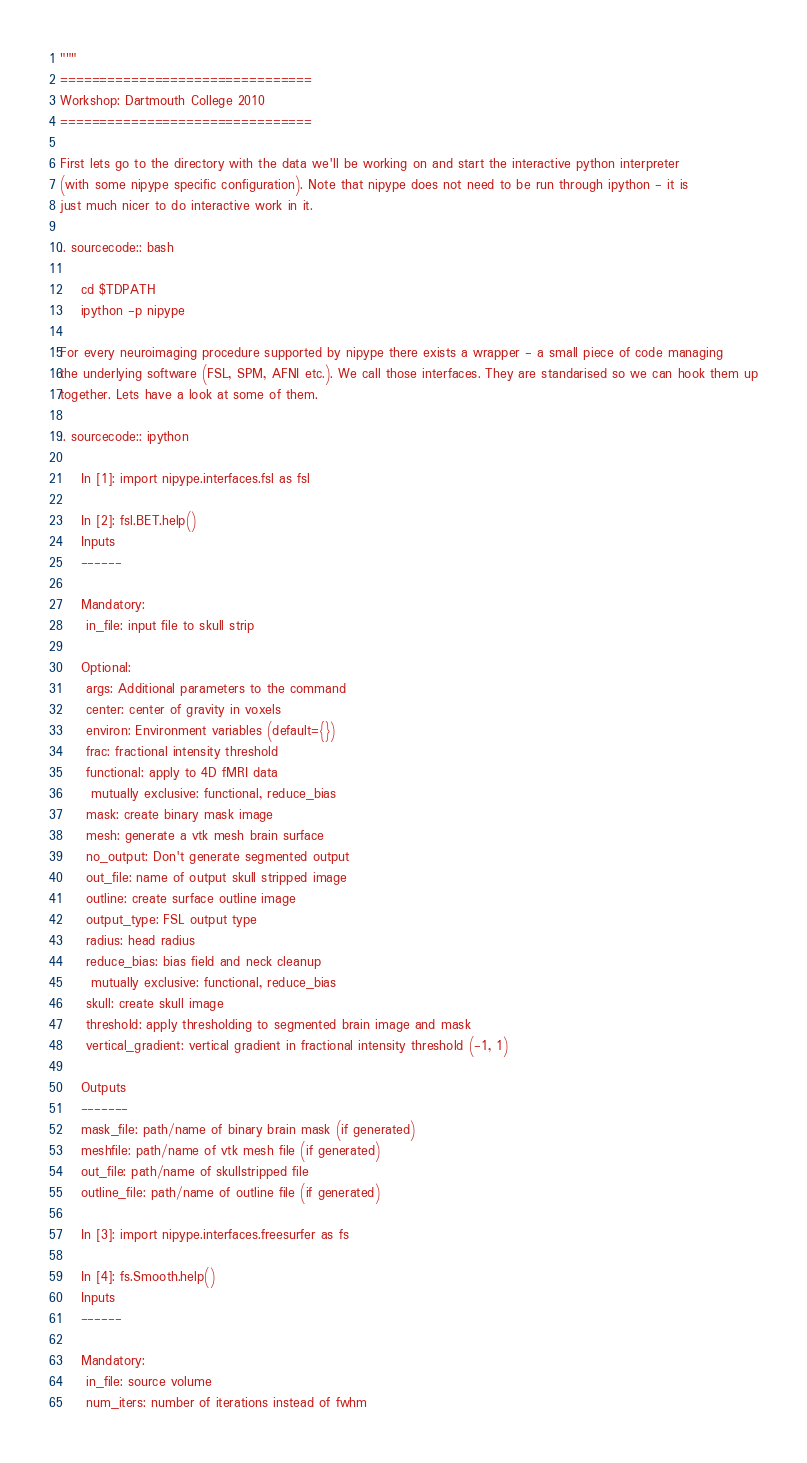Convert code to text. <code><loc_0><loc_0><loc_500><loc_500><_Python_>"""
================================
Workshop: Dartmouth College 2010
================================

First lets go to the directory with the data we'll be working on and start the interactive python interpreter
(with some nipype specific configuration). Note that nipype does not need to be run through ipython - it is
just much nicer to do interactive work in it.

.. sourcecode:: bash

    cd $TDPATH
    ipython -p nipype

For every neuroimaging procedure supported by nipype there exists a wrapper - a small piece of code managing
the underlying software (FSL, SPM, AFNI etc.). We call those interfaces. They are standarised so we can hook them up
together. Lets have a look at some of them.

.. sourcecode:: ipython

    In [1]: import nipype.interfaces.fsl as fsl

    In [2]: fsl.BET.help()
    Inputs
    ------

    Mandatory:
     in_file: input file to skull strip

    Optional:
     args: Additional parameters to the command
     center: center of gravity in voxels
     environ: Environment variables (default={})
     frac: fractional intensity threshold
     functional: apply to 4D fMRI data
      mutually exclusive: functional, reduce_bias
     mask: create binary mask image
     mesh: generate a vtk mesh brain surface
     no_output: Don't generate segmented output
     out_file: name of output skull stripped image
     outline: create surface outline image
     output_type: FSL output type
     radius: head radius
     reduce_bias: bias field and neck cleanup
      mutually exclusive: functional, reduce_bias
     skull: create skull image
     threshold: apply thresholding to segmented brain image and mask
     vertical_gradient: vertical gradient in fractional intensity threshold (-1, 1)

    Outputs
    -------
    mask_file: path/name of binary brain mask (if generated)
    meshfile: path/name of vtk mesh file (if generated)
    out_file: path/name of skullstripped file
    outline_file: path/name of outline file (if generated)

    In [3]: import nipype.interfaces.freesurfer as fs

    In [4]: fs.Smooth.help()
    Inputs
    ------

    Mandatory:
     in_file: source volume
     num_iters: number of iterations instead of fwhm</code> 